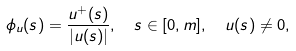Convert formula to latex. <formula><loc_0><loc_0><loc_500><loc_500>& \phi _ { u } ( s ) = \frac { u ^ { + } ( s ) } { | u ( s ) | } , \quad s \in [ 0 , m ] , \quad u ( s ) \ne 0 ,</formula> 